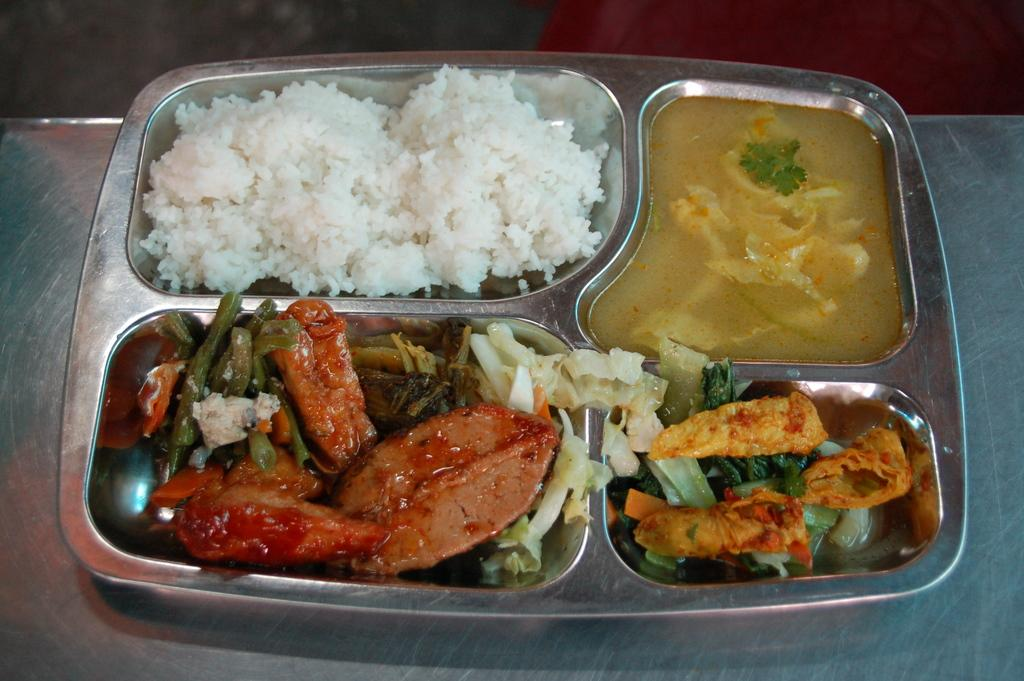What is on the plate that is visible in the image? The plate contains rice and other food items. Where is the plate located in the image? The plate is on a table. What type of celery can be seen growing in the image? There is no celery present in the image. Is it raining in the image? The image does not show any indication of rain. 